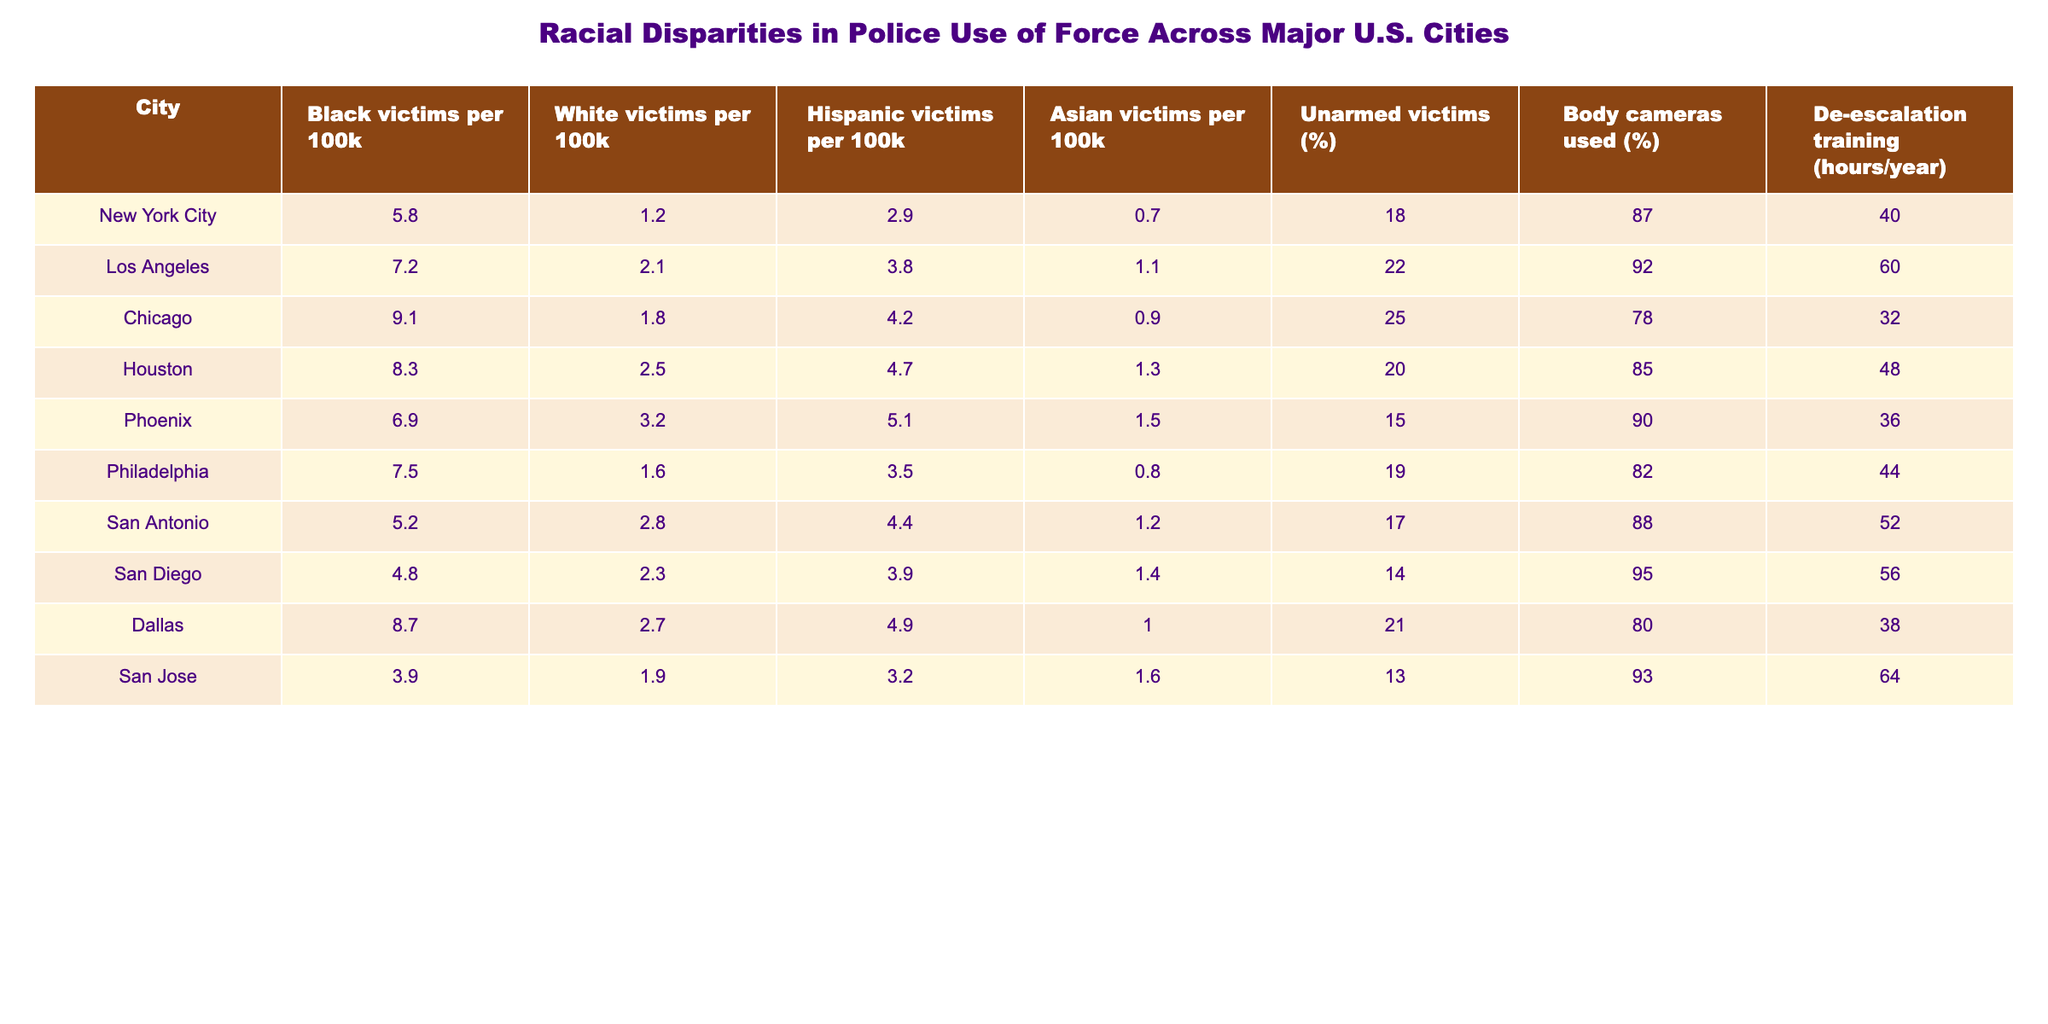What city has the highest number of Black victims per 100k? By looking at the column for Black victims per 100k, we can identify that Chicago has the highest value of 9.1.
Answer: Chicago What percentage of unarmed victims is highest among the cities? The unarmed victims percentage can be found in the last column. The highest percentage is 25% in Chicago.
Answer: 25% What is the average number of White victims per 100k across all cities? We add the values for White victims per 100k from all cities: (1.2 + 2.1 + 1.8 + 2.5 + 3.2 + 1.6 + 2.8 + 2.3 + 2.7 + 1.9) = 20.1. There are 10 cities, so the average is 20.1 / 10 = 2.01.
Answer: 2.01 Which city uses body cameras the least often, and what is that percentage? We need to check the body cameras used percentage across all cities. San Jose has the lowest value at 93%.
Answer: 93% Is it true that San Antonio has a higher percentage of body cameras used compared to New York City? We compare the body cameras used percentage for both cities: San Antonio is 88% and New York City is 87%. Thus, San Antonio has a higher percentage.
Answer: True Which city shows a significant difference between Black and White victims per 100k? By reviewing the differences in Black and White victims per 100k for each city, we see that Chicago has the largest disparity, with 9.1 Black victims versus 1.8 White victims, resulting in a difference of 7.3.
Answer: Chicago What is the standard difference between the highest and lowest values for Hispanic victims per 100k? The highest value is in Phoenix (5.1) and the lowest is in San Jose (3.2). The difference is 5.1 - 3.2 = 1.9.
Answer: 1.9 Which city has the lowest percentage of unarmed victims? By examining the unarmed victims percentage column, we see that San Diego has the lowest at 14%.
Answer: San Diego Are there any cities where the number of Hispanic victims per 100k exceeds the number of White victims per 100k? We evaluate the relevant columns and find that Los Angeles (3.8) and Houston (4.7) exceed the number of White victims (2.1 and 2.5 respectively).
Answer: Yes How does the average number of Black victims compare to the average number of Asian victims per 100k across the cities? The average number of Black victims is calculated by summing all values (5.8 + 7.2 + 9.1 + 8.3 + 6.9 + 7.5 + 5.2 + 4.8 + 8.7 + 3.9 = 67.4), which yields an average of 67.4 / 10 = 6.74. The average for Asian victims is (0.7 + 1.1 + 0.9 + 1.3 + 1.5 + 0.8 + 1.2 + 1.4 + 1.0 + 1.6 = 12.5), with an average of 12.5 / 10 = 1.25. Comparing both averages, 6.74 > 1.25, so Black victims per 100k are higher on average.
Answer: Black victims are higher than Asian victims 